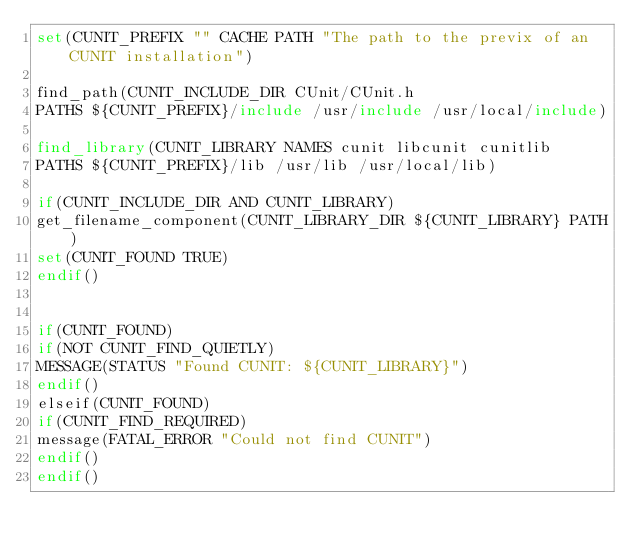<code> <loc_0><loc_0><loc_500><loc_500><_CMake_>set(CUNIT_PREFIX "" CACHE PATH "The path to the previx of an CUNIT installation")

find_path(CUNIT_INCLUDE_DIR CUnit/CUnit.h
PATHS ${CUNIT_PREFIX}/include /usr/include /usr/local/include)

find_library(CUNIT_LIBRARY NAMES cunit libcunit cunitlib
PATHS ${CUNIT_PREFIX}/lib /usr/lib /usr/local/lib)

if(CUNIT_INCLUDE_DIR AND CUNIT_LIBRARY)
get_filename_component(CUNIT_LIBRARY_DIR ${CUNIT_LIBRARY} PATH)
set(CUNIT_FOUND TRUE)
endif()


if(CUNIT_FOUND)
if(NOT CUNIT_FIND_QUIETLY)
MESSAGE(STATUS "Found CUNIT: ${CUNIT_LIBRARY}")
endif()
elseif(CUNIT_FOUND)
if(CUNIT_FIND_REQUIRED)
message(FATAL_ERROR "Could not find CUNIT")
endif()
endif()
</code> 